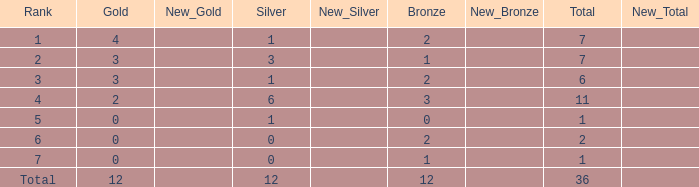What is the highest number of silver medals for a team with total less than 1? None. 